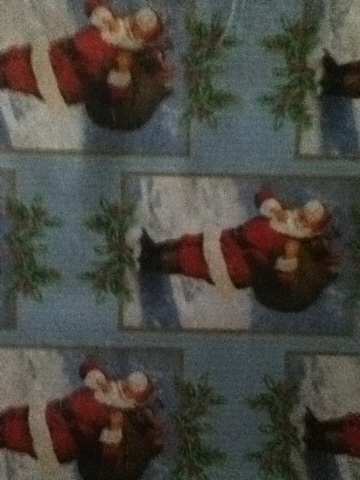A very creative question: If this wrapping paper was magic, what kind of spell would it cast when used? If this wrapping paper was magic, it would cast a spell of 'Joyful Christmas Spirit'. When a gift is wrapped in this paper and given to someone, it would instantly bring a sense of warmth and joy to their heart, filling them with the holiday spirit. The spell could also enhance the festive atmosphere around the gift, making twinkling lights appear and gentle Christmas music play in the air whenever the present is near. Additionally, it might even cause a gentle snowfall indoors, adding a touch of magic to the holiday celebration. 